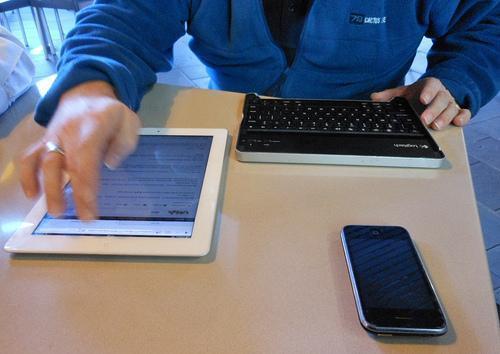How many devices are on the table?
Give a very brief answer. 3. 